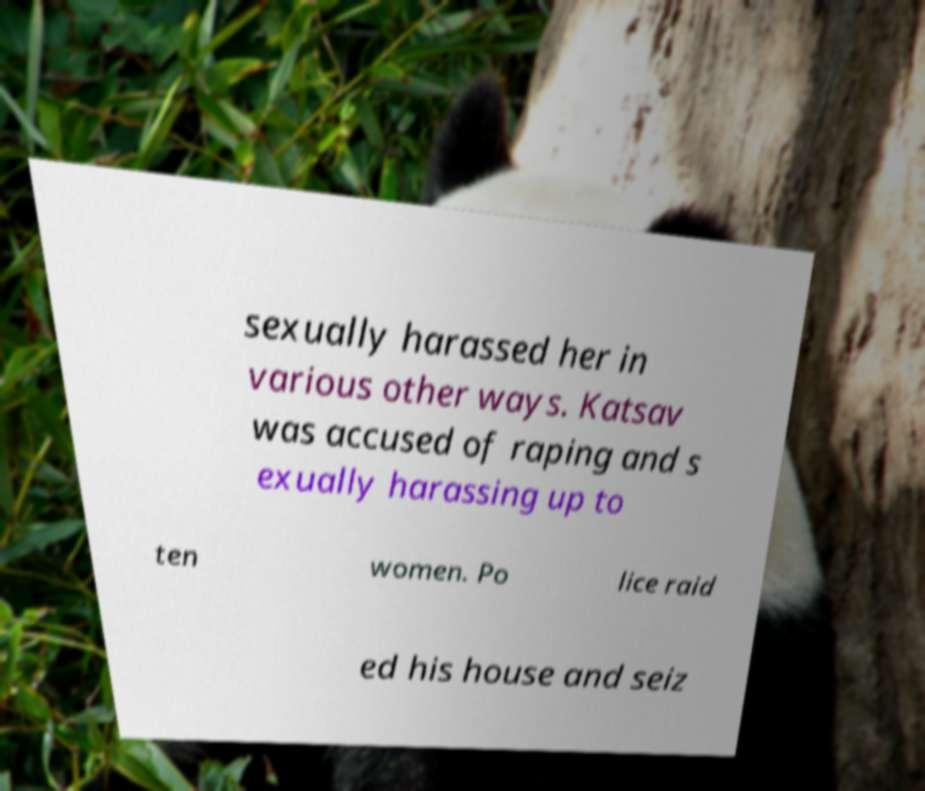Could you assist in decoding the text presented in this image and type it out clearly? sexually harassed her in various other ways. Katsav was accused of raping and s exually harassing up to ten women. Po lice raid ed his house and seiz 